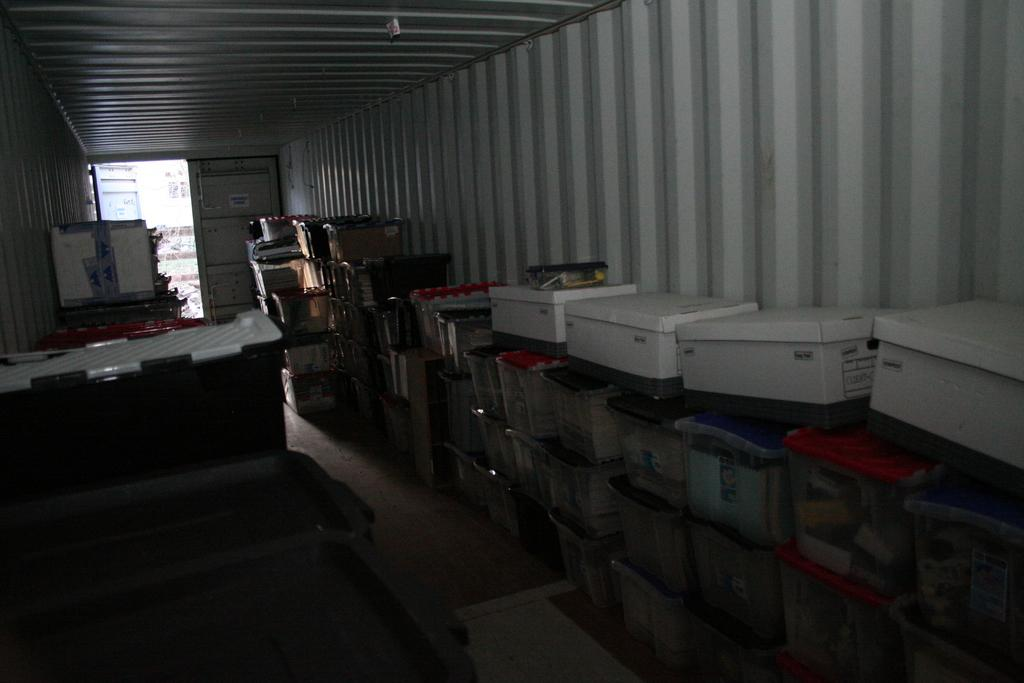Where was the image taken? The image was taken inside a shed. What can be seen in the image besides the shed? There are many boxes and containers in the image. What is the surface that the boxes and containers are placed on? There is a floor visible in the image. What is the entrance to the shed in the image? There is a door in the background of the image. What type of fish can be seen swimming in the background of the image? There are no fish present in the image; it was taken inside a shed with boxes and containers. How many cattle are visible in the image? There are no cattle present in the image; it features a shed with boxes and containers. 